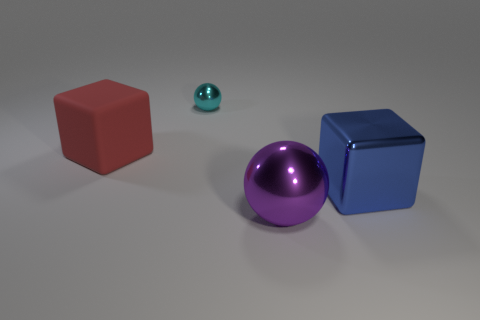How many objects are there in total in the image? There are four objects in the image: two cubes, one sphere, and one smaller sphere. 